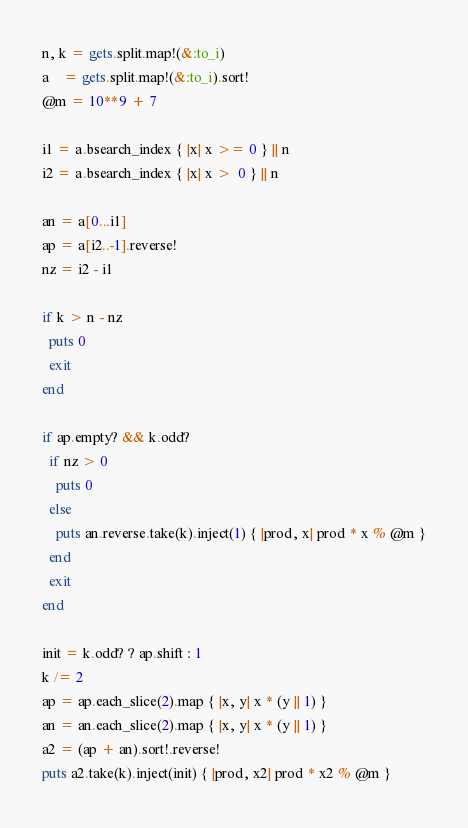<code> <loc_0><loc_0><loc_500><loc_500><_Ruby_>n, k = gets.split.map!(&:to_i)
a    = gets.split.map!(&:to_i).sort!
@m = 10**9 + 7

i1 = a.bsearch_index { |x| x >= 0 } || n
i2 = a.bsearch_index { |x| x >  0 } || n

an = a[0...i1]
ap = a[i2..-1].reverse!
nz = i2 - i1

if k > n - nz
  puts 0
  exit
end

if ap.empty? && k.odd?
  if nz > 0
    puts 0
  else
    puts an.reverse.take(k).inject(1) { |prod, x| prod * x % @m }
  end
  exit
end

init = k.odd? ? ap.shift : 1
k /= 2
ap = ap.each_slice(2).map { |x, y| x * (y || 1) }
an = an.each_slice(2).map { |x, y| x * (y || 1) }
a2 = (ap + an).sort!.reverse!
puts a2.take(k).inject(init) { |prod, x2| prod * x2 % @m }
</code> 